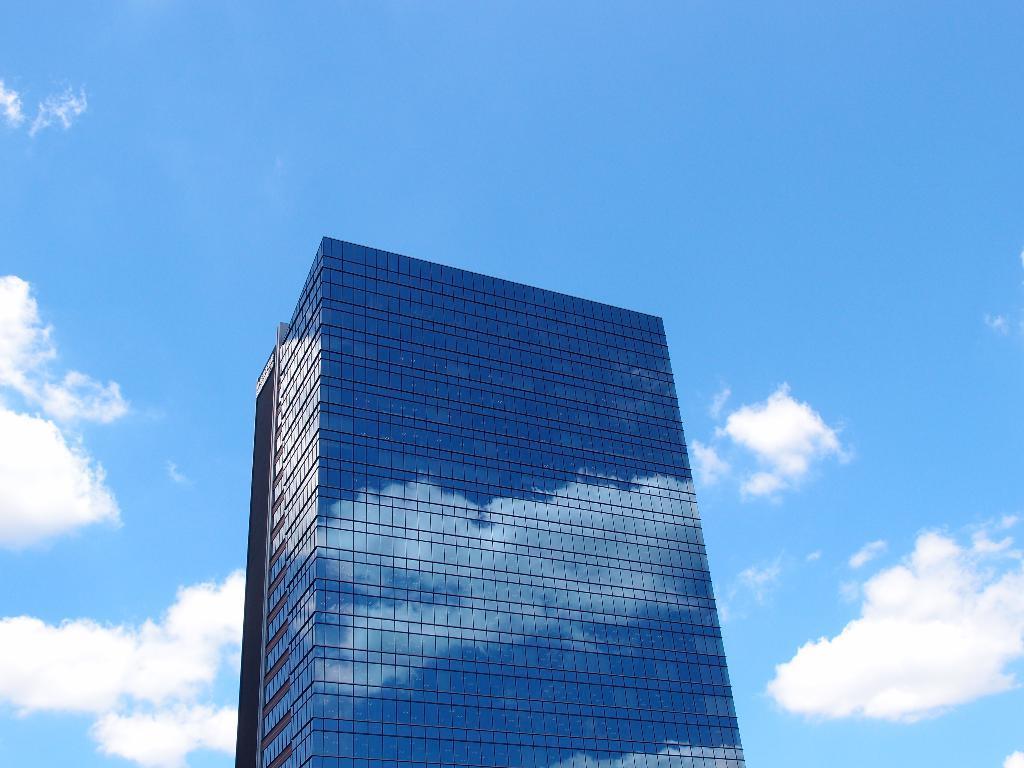Can you describe this image briefly? In this image in the center there is a building, and at the top there is sky. 